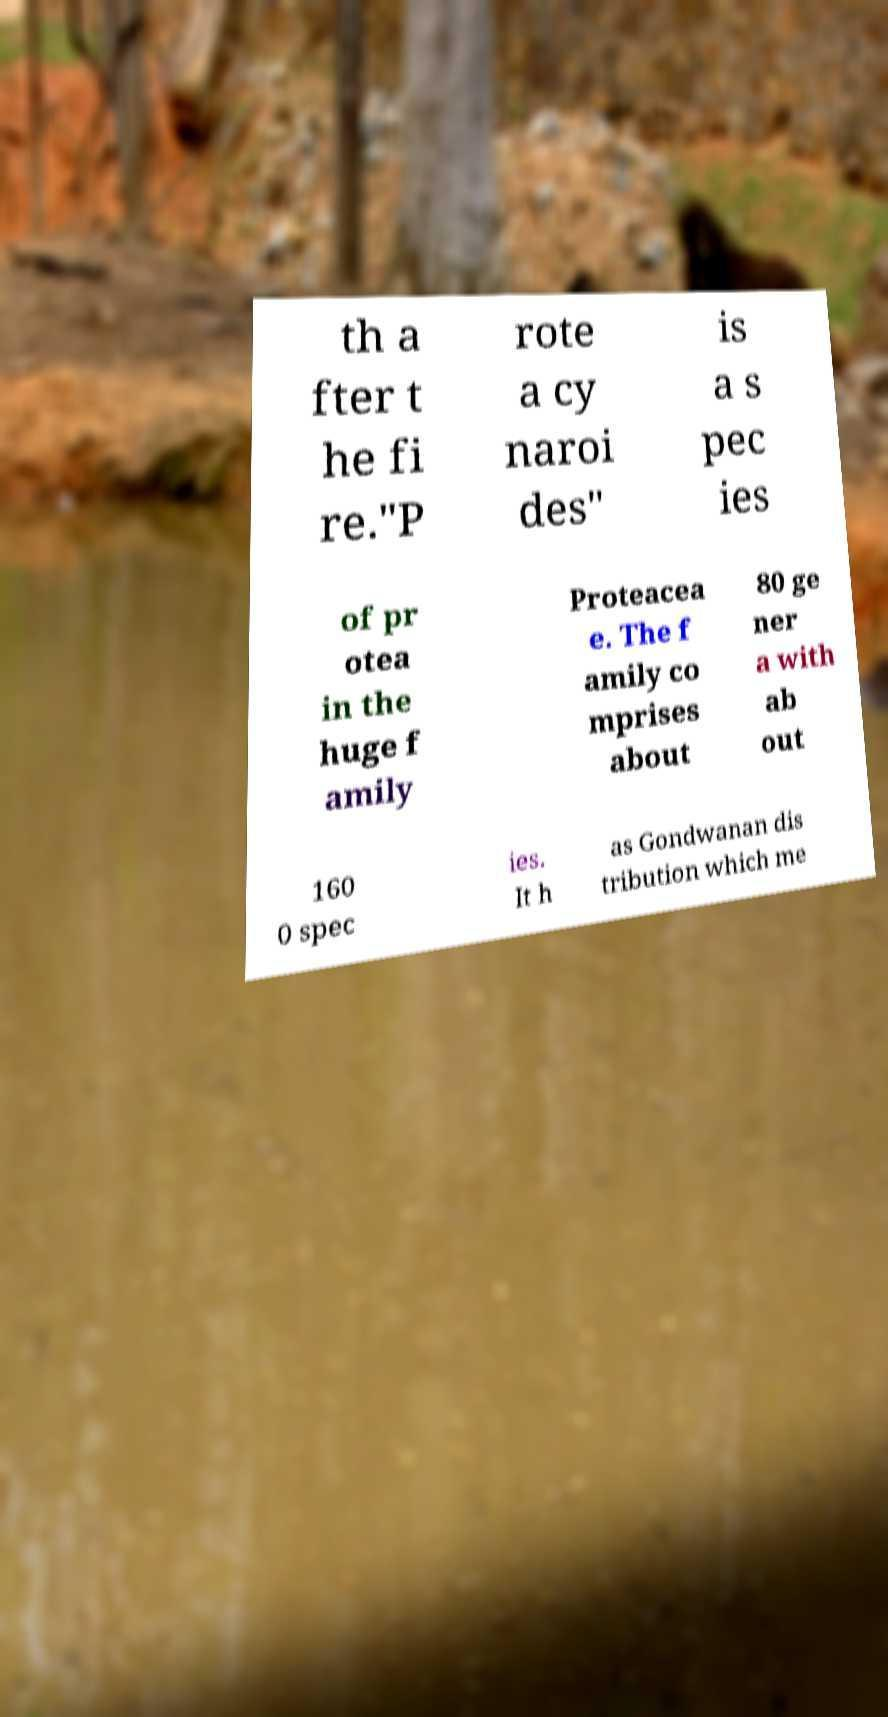Please identify and transcribe the text found in this image. th a fter t he fi re."P rote a cy naroi des" is a s pec ies of pr otea in the huge f amily Proteacea e. The f amily co mprises about 80 ge ner a with ab out 160 0 spec ies. It h as Gondwanan dis tribution which me 